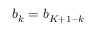<formula> <loc_0><loc_0><loc_500><loc_500>b _ { k } = b _ { K + 1 - k }</formula> 